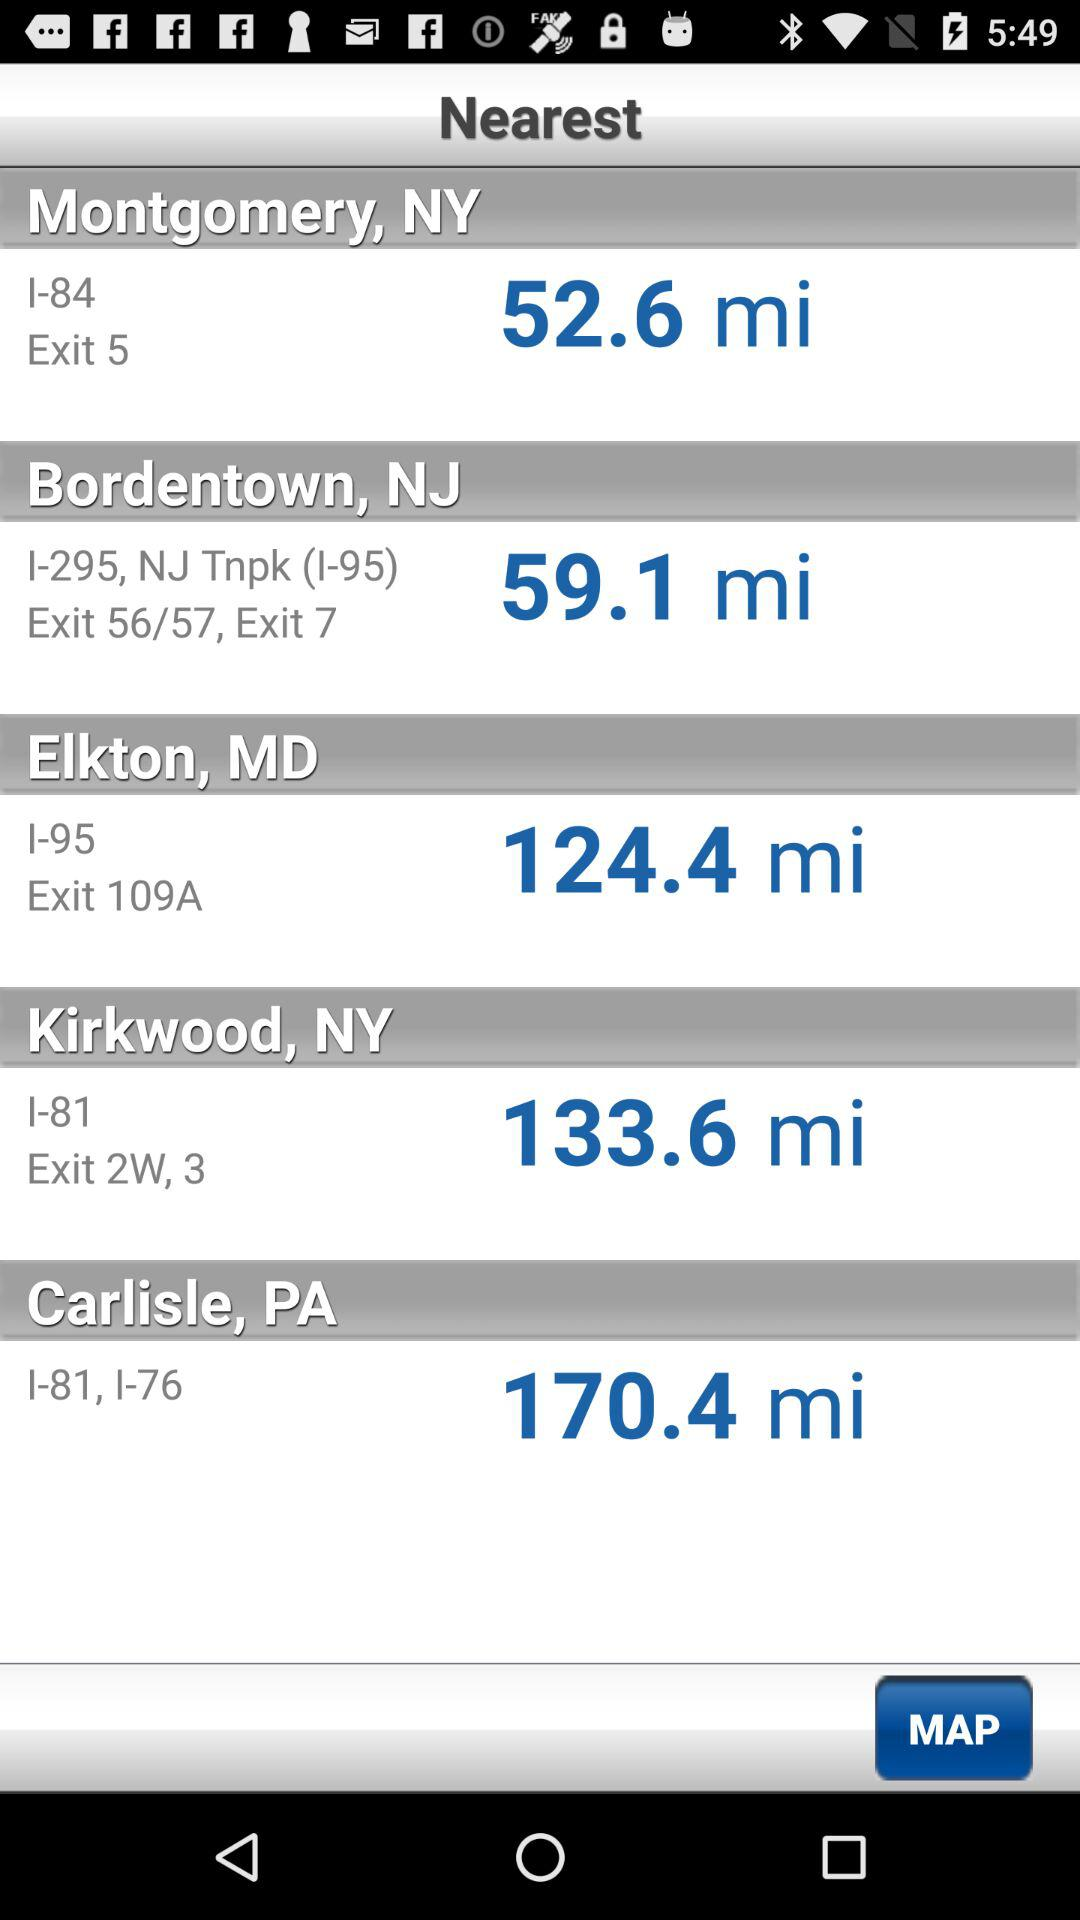How many miles are displayed in Montgomery, NY? In Montgomery, NY, 52.6 miles are displayed. 